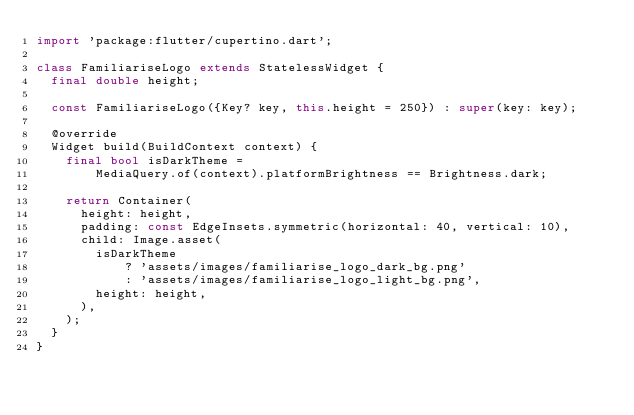Convert code to text. <code><loc_0><loc_0><loc_500><loc_500><_Dart_>import 'package:flutter/cupertino.dart';

class FamiliariseLogo extends StatelessWidget {
  final double height;

  const FamiliariseLogo({Key? key, this.height = 250}) : super(key: key);

  @override
  Widget build(BuildContext context) {
    final bool isDarkTheme =
        MediaQuery.of(context).platformBrightness == Brightness.dark;

    return Container(
      height: height,
      padding: const EdgeInsets.symmetric(horizontal: 40, vertical: 10),
      child: Image.asset(
        isDarkTheme
            ? 'assets/images/familiarise_logo_dark_bg.png'
            : 'assets/images/familiarise_logo_light_bg.png',
        height: height,
      ),
    );
  }
}
</code> 